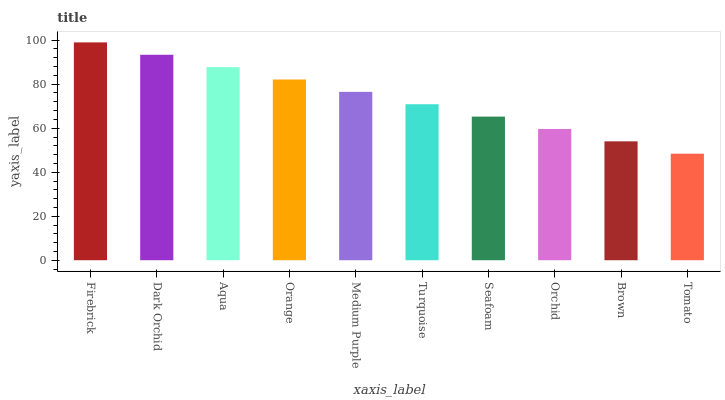Is Tomato the minimum?
Answer yes or no. Yes. Is Firebrick the maximum?
Answer yes or no. Yes. Is Dark Orchid the minimum?
Answer yes or no. No. Is Dark Orchid the maximum?
Answer yes or no. No. Is Firebrick greater than Dark Orchid?
Answer yes or no. Yes. Is Dark Orchid less than Firebrick?
Answer yes or no. Yes. Is Dark Orchid greater than Firebrick?
Answer yes or no. No. Is Firebrick less than Dark Orchid?
Answer yes or no. No. Is Medium Purple the high median?
Answer yes or no. Yes. Is Turquoise the low median?
Answer yes or no. Yes. Is Orange the high median?
Answer yes or no. No. Is Orange the low median?
Answer yes or no. No. 